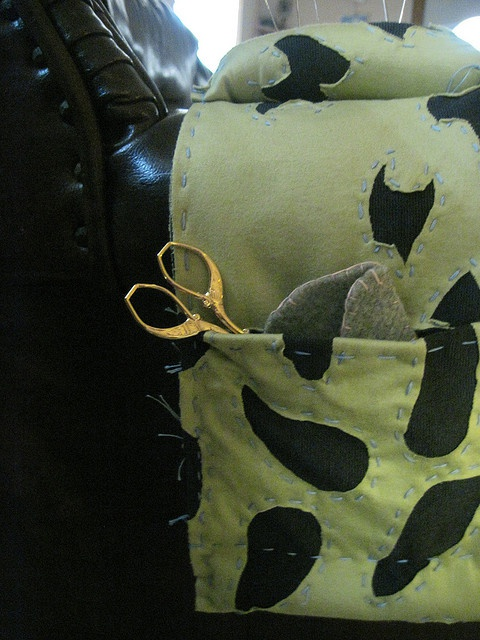Describe the objects in this image and their specific colors. I can see couch in gray, black, and darkgray tones, chair in black, gray, blue, and darkblue tones, and scissors in black, darkgreen, and tan tones in this image. 